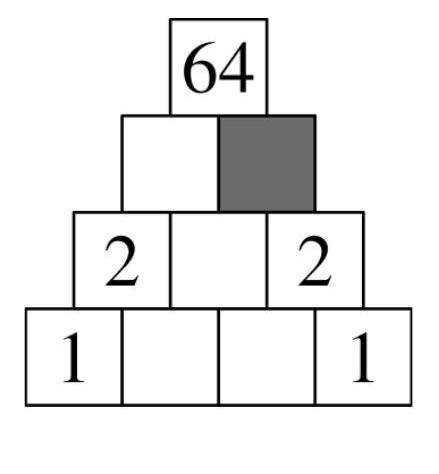Is there a pattern or symmetry to observe in the number placement in the multiplication pyramid? Yes, there's a noticeable symmetry and pattern in the placement of numbers in the multiplication pyramid. The pyramid works such that each layer beneath the top compound multiplicatively to form the next layer, often showcasing a mirror-like symmetry. For instance, if you notice the base of this pyramid has pairs of identical numbers (1 and 1, 2 and 2), showing bilateral symmetry. This symmetry helps in deducing missing numbers if any from the known values. Does the pyramid retain its properties if we change the base numbers? Absolutely, changing the base numbers will still retain the properties of the multiplication pyramid, but it will produce different numbers on the higher levels. Each value would still be computed by multiplying the two numbers directly beneath it, following the same rule, albeit leading to potentially vastly different results at the top. 